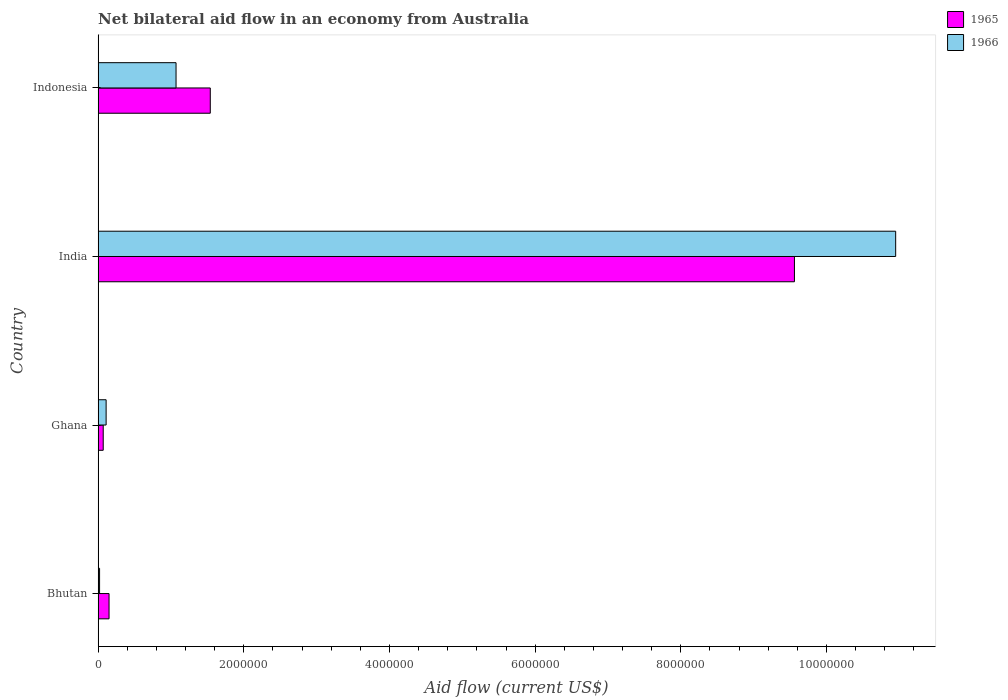How many different coloured bars are there?
Your answer should be very brief. 2. How many groups of bars are there?
Keep it short and to the point. 4. Are the number of bars per tick equal to the number of legend labels?
Offer a very short reply. Yes. Are the number of bars on each tick of the Y-axis equal?
Offer a very short reply. Yes. How many bars are there on the 2nd tick from the top?
Your response must be concise. 2. How many bars are there on the 2nd tick from the bottom?
Ensure brevity in your answer.  2. What is the label of the 1st group of bars from the top?
Make the answer very short. Indonesia. What is the net bilateral aid flow in 1965 in India?
Your response must be concise. 9.56e+06. Across all countries, what is the maximum net bilateral aid flow in 1965?
Provide a short and direct response. 9.56e+06. In which country was the net bilateral aid flow in 1966 minimum?
Make the answer very short. Bhutan. What is the total net bilateral aid flow in 1966 in the graph?
Offer a terse response. 1.22e+07. What is the difference between the net bilateral aid flow in 1965 in Ghana and that in India?
Provide a succinct answer. -9.49e+06. What is the difference between the net bilateral aid flow in 1965 in Bhutan and the net bilateral aid flow in 1966 in Indonesia?
Ensure brevity in your answer.  -9.20e+05. What is the average net bilateral aid flow in 1965 per country?
Ensure brevity in your answer.  2.83e+06. What is the ratio of the net bilateral aid flow in 1966 in Ghana to that in Indonesia?
Provide a short and direct response. 0.1. Is the difference between the net bilateral aid flow in 1965 in India and Indonesia greater than the difference between the net bilateral aid flow in 1966 in India and Indonesia?
Give a very brief answer. No. What is the difference between the highest and the second highest net bilateral aid flow in 1965?
Your answer should be compact. 8.02e+06. What is the difference between the highest and the lowest net bilateral aid flow in 1965?
Keep it short and to the point. 9.49e+06. What does the 2nd bar from the top in Bhutan represents?
Keep it short and to the point. 1965. What does the 2nd bar from the bottom in Indonesia represents?
Your answer should be compact. 1966. How many bars are there?
Provide a succinct answer. 8. Are all the bars in the graph horizontal?
Your answer should be very brief. Yes. How many countries are there in the graph?
Your answer should be very brief. 4. Does the graph contain grids?
Provide a short and direct response. No. Where does the legend appear in the graph?
Offer a very short reply. Top right. What is the title of the graph?
Ensure brevity in your answer.  Net bilateral aid flow in an economy from Australia. What is the label or title of the Y-axis?
Offer a very short reply. Country. What is the Aid flow (current US$) in 1965 in Bhutan?
Ensure brevity in your answer.  1.50e+05. What is the Aid flow (current US$) of 1965 in Ghana?
Your response must be concise. 7.00e+04. What is the Aid flow (current US$) in 1965 in India?
Make the answer very short. 9.56e+06. What is the Aid flow (current US$) of 1966 in India?
Provide a succinct answer. 1.10e+07. What is the Aid flow (current US$) in 1965 in Indonesia?
Your response must be concise. 1.54e+06. What is the Aid flow (current US$) of 1966 in Indonesia?
Offer a terse response. 1.07e+06. Across all countries, what is the maximum Aid flow (current US$) of 1965?
Your response must be concise. 9.56e+06. Across all countries, what is the maximum Aid flow (current US$) of 1966?
Give a very brief answer. 1.10e+07. Across all countries, what is the minimum Aid flow (current US$) of 1965?
Make the answer very short. 7.00e+04. What is the total Aid flow (current US$) of 1965 in the graph?
Offer a very short reply. 1.13e+07. What is the total Aid flow (current US$) of 1966 in the graph?
Provide a succinct answer. 1.22e+07. What is the difference between the Aid flow (current US$) in 1965 in Bhutan and that in Ghana?
Make the answer very short. 8.00e+04. What is the difference between the Aid flow (current US$) in 1966 in Bhutan and that in Ghana?
Your answer should be compact. -9.00e+04. What is the difference between the Aid flow (current US$) of 1965 in Bhutan and that in India?
Keep it short and to the point. -9.41e+06. What is the difference between the Aid flow (current US$) in 1966 in Bhutan and that in India?
Your answer should be very brief. -1.09e+07. What is the difference between the Aid flow (current US$) in 1965 in Bhutan and that in Indonesia?
Ensure brevity in your answer.  -1.39e+06. What is the difference between the Aid flow (current US$) in 1966 in Bhutan and that in Indonesia?
Provide a succinct answer. -1.05e+06. What is the difference between the Aid flow (current US$) in 1965 in Ghana and that in India?
Your response must be concise. -9.49e+06. What is the difference between the Aid flow (current US$) in 1966 in Ghana and that in India?
Provide a short and direct response. -1.08e+07. What is the difference between the Aid flow (current US$) of 1965 in Ghana and that in Indonesia?
Make the answer very short. -1.47e+06. What is the difference between the Aid flow (current US$) in 1966 in Ghana and that in Indonesia?
Your answer should be compact. -9.60e+05. What is the difference between the Aid flow (current US$) of 1965 in India and that in Indonesia?
Offer a very short reply. 8.02e+06. What is the difference between the Aid flow (current US$) in 1966 in India and that in Indonesia?
Make the answer very short. 9.88e+06. What is the difference between the Aid flow (current US$) of 1965 in Bhutan and the Aid flow (current US$) of 1966 in Ghana?
Offer a terse response. 4.00e+04. What is the difference between the Aid flow (current US$) in 1965 in Bhutan and the Aid flow (current US$) in 1966 in India?
Your response must be concise. -1.08e+07. What is the difference between the Aid flow (current US$) in 1965 in Bhutan and the Aid flow (current US$) in 1966 in Indonesia?
Provide a short and direct response. -9.20e+05. What is the difference between the Aid flow (current US$) of 1965 in Ghana and the Aid flow (current US$) of 1966 in India?
Offer a very short reply. -1.09e+07. What is the difference between the Aid flow (current US$) of 1965 in India and the Aid flow (current US$) of 1966 in Indonesia?
Offer a terse response. 8.49e+06. What is the average Aid flow (current US$) in 1965 per country?
Ensure brevity in your answer.  2.83e+06. What is the average Aid flow (current US$) in 1966 per country?
Make the answer very short. 3.04e+06. What is the difference between the Aid flow (current US$) of 1965 and Aid flow (current US$) of 1966 in India?
Offer a very short reply. -1.39e+06. What is the difference between the Aid flow (current US$) in 1965 and Aid flow (current US$) in 1966 in Indonesia?
Your response must be concise. 4.70e+05. What is the ratio of the Aid flow (current US$) of 1965 in Bhutan to that in Ghana?
Give a very brief answer. 2.14. What is the ratio of the Aid flow (current US$) of 1966 in Bhutan to that in Ghana?
Keep it short and to the point. 0.18. What is the ratio of the Aid flow (current US$) in 1965 in Bhutan to that in India?
Offer a terse response. 0.02. What is the ratio of the Aid flow (current US$) of 1966 in Bhutan to that in India?
Your response must be concise. 0. What is the ratio of the Aid flow (current US$) of 1965 in Bhutan to that in Indonesia?
Provide a short and direct response. 0.1. What is the ratio of the Aid flow (current US$) of 1966 in Bhutan to that in Indonesia?
Give a very brief answer. 0.02. What is the ratio of the Aid flow (current US$) of 1965 in Ghana to that in India?
Your response must be concise. 0.01. What is the ratio of the Aid flow (current US$) of 1966 in Ghana to that in India?
Provide a succinct answer. 0.01. What is the ratio of the Aid flow (current US$) in 1965 in Ghana to that in Indonesia?
Offer a terse response. 0.05. What is the ratio of the Aid flow (current US$) in 1966 in Ghana to that in Indonesia?
Give a very brief answer. 0.1. What is the ratio of the Aid flow (current US$) in 1965 in India to that in Indonesia?
Make the answer very short. 6.21. What is the ratio of the Aid flow (current US$) of 1966 in India to that in Indonesia?
Keep it short and to the point. 10.23. What is the difference between the highest and the second highest Aid flow (current US$) of 1965?
Your answer should be very brief. 8.02e+06. What is the difference between the highest and the second highest Aid flow (current US$) in 1966?
Provide a succinct answer. 9.88e+06. What is the difference between the highest and the lowest Aid flow (current US$) of 1965?
Make the answer very short. 9.49e+06. What is the difference between the highest and the lowest Aid flow (current US$) in 1966?
Ensure brevity in your answer.  1.09e+07. 